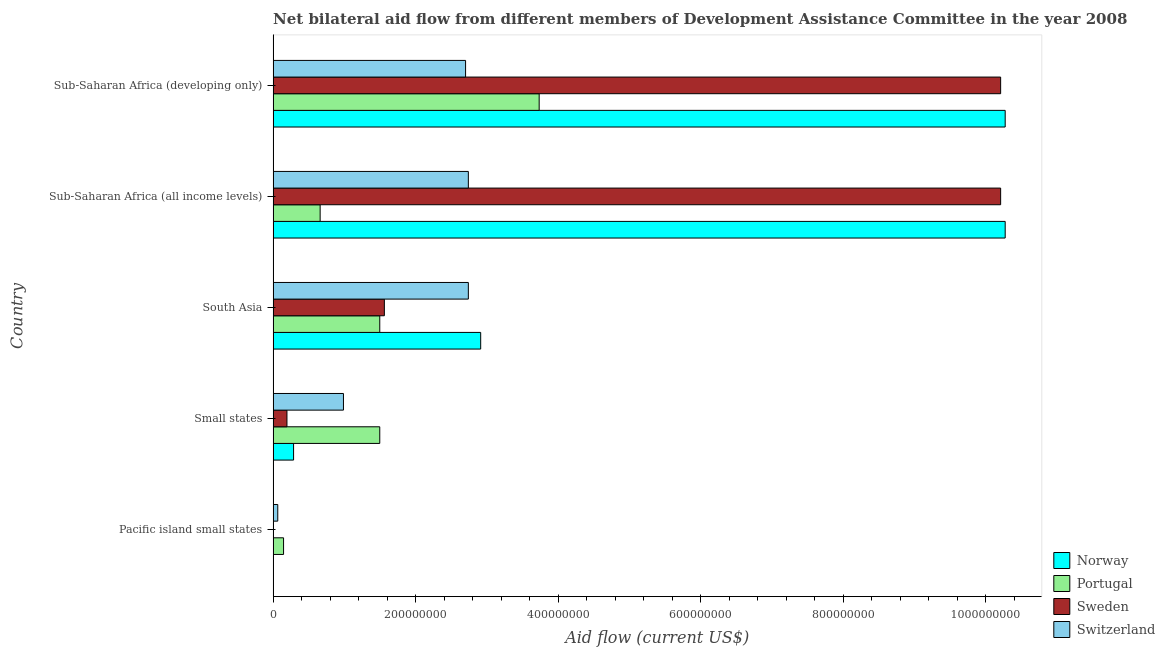How many different coloured bars are there?
Provide a succinct answer. 4. How many groups of bars are there?
Provide a short and direct response. 5. Are the number of bars per tick equal to the number of legend labels?
Provide a succinct answer. Yes. How many bars are there on the 1st tick from the bottom?
Your answer should be compact. 4. What is the label of the 5th group of bars from the top?
Give a very brief answer. Pacific island small states. In how many cases, is the number of bars for a given country not equal to the number of legend labels?
Offer a very short reply. 0. What is the amount of aid given by portugal in Small states?
Give a very brief answer. 1.50e+08. Across all countries, what is the maximum amount of aid given by switzerland?
Provide a short and direct response. 2.74e+08. Across all countries, what is the minimum amount of aid given by sweden?
Your answer should be very brief. 7.00e+04. In which country was the amount of aid given by norway maximum?
Make the answer very short. Sub-Saharan Africa (all income levels). In which country was the amount of aid given by norway minimum?
Give a very brief answer. Pacific island small states. What is the total amount of aid given by portugal in the graph?
Provide a succinct answer. 7.53e+08. What is the difference between the amount of aid given by norway in Small states and that in South Asia?
Ensure brevity in your answer.  -2.63e+08. What is the difference between the amount of aid given by portugal in South Asia and the amount of aid given by switzerland in Small states?
Give a very brief answer. 5.10e+07. What is the average amount of aid given by portugal per country?
Your response must be concise. 1.51e+08. What is the difference between the amount of aid given by portugal and amount of aid given by norway in Sub-Saharan Africa (all income levels)?
Offer a very short reply. -9.61e+08. In how many countries, is the amount of aid given by portugal greater than 680000000 US$?
Provide a short and direct response. 0. What is the ratio of the amount of aid given by sweden in South Asia to that in Sub-Saharan Africa (developing only)?
Offer a very short reply. 0.15. Is the amount of aid given by norway in Sub-Saharan Africa (all income levels) less than that in Sub-Saharan Africa (developing only)?
Offer a terse response. No. What is the difference between the highest and the lowest amount of aid given by portugal?
Offer a terse response. 3.59e+08. In how many countries, is the amount of aid given by sweden greater than the average amount of aid given by sweden taken over all countries?
Ensure brevity in your answer.  2. Is it the case that in every country, the sum of the amount of aid given by sweden and amount of aid given by portugal is greater than the sum of amount of aid given by switzerland and amount of aid given by norway?
Your response must be concise. No. What does the 3rd bar from the top in South Asia represents?
Make the answer very short. Portugal. What does the 4th bar from the bottom in Sub-Saharan Africa (developing only) represents?
Your response must be concise. Switzerland. Is it the case that in every country, the sum of the amount of aid given by norway and amount of aid given by portugal is greater than the amount of aid given by sweden?
Offer a terse response. Yes. Does the graph contain any zero values?
Keep it short and to the point. No. How are the legend labels stacked?
Your answer should be very brief. Vertical. What is the title of the graph?
Provide a short and direct response. Net bilateral aid flow from different members of Development Assistance Committee in the year 2008. Does "Efficiency of custom clearance process" appear as one of the legend labels in the graph?
Your response must be concise. No. What is the label or title of the Y-axis?
Offer a very short reply. Country. What is the Aid flow (current US$) of Portugal in Pacific island small states?
Offer a very short reply. 1.46e+07. What is the Aid flow (current US$) of Sweden in Pacific island small states?
Ensure brevity in your answer.  7.00e+04. What is the Aid flow (current US$) of Switzerland in Pacific island small states?
Your response must be concise. 6.52e+06. What is the Aid flow (current US$) in Norway in Small states?
Make the answer very short. 2.87e+07. What is the Aid flow (current US$) in Portugal in Small states?
Give a very brief answer. 1.50e+08. What is the Aid flow (current US$) of Sweden in Small states?
Ensure brevity in your answer.  1.94e+07. What is the Aid flow (current US$) in Switzerland in Small states?
Your answer should be compact. 9.87e+07. What is the Aid flow (current US$) of Norway in South Asia?
Your response must be concise. 2.91e+08. What is the Aid flow (current US$) of Portugal in South Asia?
Keep it short and to the point. 1.50e+08. What is the Aid flow (current US$) in Sweden in South Asia?
Keep it short and to the point. 1.56e+08. What is the Aid flow (current US$) in Switzerland in South Asia?
Keep it short and to the point. 2.74e+08. What is the Aid flow (current US$) in Norway in Sub-Saharan Africa (all income levels)?
Your response must be concise. 1.03e+09. What is the Aid flow (current US$) of Portugal in Sub-Saharan Africa (all income levels)?
Provide a short and direct response. 6.60e+07. What is the Aid flow (current US$) of Sweden in Sub-Saharan Africa (all income levels)?
Provide a short and direct response. 1.02e+09. What is the Aid flow (current US$) of Switzerland in Sub-Saharan Africa (all income levels)?
Your answer should be very brief. 2.74e+08. What is the Aid flow (current US$) of Norway in Sub-Saharan Africa (developing only)?
Give a very brief answer. 1.03e+09. What is the Aid flow (current US$) in Portugal in Sub-Saharan Africa (developing only)?
Provide a short and direct response. 3.73e+08. What is the Aid flow (current US$) of Sweden in Sub-Saharan Africa (developing only)?
Your answer should be very brief. 1.02e+09. What is the Aid flow (current US$) of Switzerland in Sub-Saharan Africa (developing only)?
Make the answer very short. 2.70e+08. Across all countries, what is the maximum Aid flow (current US$) of Norway?
Provide a short and direct response. 1.03e+09. Across all countries, what is the maximum Aid flow (current US$) in Portugal?
Make the answer very short. 3.73e+08. Across all countries, what is the maximum Aid flow (current US$) in Sweden?
Give a very brief answer. 1.02e+09. Across all countries, what is the maximum Aid flow (current US$) in Switzerland?
Offer a terse response. 2.74e+08. Across all countries, what is the minimum Aid flow (current US$) in Portugal?
Provide a short and direct response. 1.46e+07. Across all countries, what is the minimum Aid flow (current US$) of Sweden?
Give a very brief answer. 7.00e+04. Across all countries, what is the minimum Aid flow (current US$) of Switzerland?
Make the answer very short. 6.52e+06. What is the total Aid flow (current US$) in Norway in the graph?
Provide a succinct answer. 2.38e+09. What is the total Aid flow (current US$) in Portugal in the graph?
Provide a succinct answer. 7.53e+08. What is the total Aid flow (current US$) of Sweden in the graph?
Make the answer very short. 2.22e+09. What is the total Aid flow (current US$) of Switzerland in the graph?
Provide a short and direct response. 9.23e+08. What is the difference between the Aid flow (current US$) of Norway in Pacific island small states and that in Small states?
Keep it short and to the point. -2.87e+07. What is the difference between the Aid flow (current US$) of Portugal in Pacific island small states and that in Small states?
Provide a succinct answer. -1.35e+08. What is the difference between the Aid flow (current US$) in Sweden in Pacific island small states and that in Small states?
Offer a very short reply. -1.93e+07. What is the difference between the Aid flow (current US$) in Switzerland in Pacific island small states and that in Small states?
Provide a succinct answer. -9.22e+07. What is the difference between the Aid flow (current US$) in Norway in Pacific island small states and that in South Asia?
Ensure brevity in your answer.  -2.91e+08. What is the difference between the Aid flow (current US$) of Portugal in Pacific island small states and that in South Asia?
Provide a short and direct response. -1.35e+08. What is the difference between the Aid flow (current US$) in Sweden in Pacific island small states and that in South Asia?
Offer a terse response. -1.56e+08. What is the difference between the Aid flow (current US$) of Switzerland in Pacific island small states and that in South Asia?
Provide a short and direct response. -2.67e+08. What is the difference between the Aid flow (current US$) in Norway in Pacific island small states and that in Sub-Saharan Africa (all income levels)?
Make the answer very short. -1.03e+09. What is the difference between the Aid flow (current US$) of Portugal in Pacific island small states and that in Sub-Saharan Africa (all income levels)?
Make the answer very short. -5.14e+07. What is the difference between the Aid flow (current US$) in Sweden in Pacific island small states and that in Sub-Saharan Africa (all income levels)?
Give a very brief answer. -1.02e+09. What is the difference between the Aid flow (current US$) of Switzerland in Pacific island small states and that in Sub-Saharan Africa (all income levels)?
Keep it short and to the point. -2.67e+08. What is the difference between the Aid flow (current US$) of Norway in Pacific island small states and that in Sub-Saharan Africa (developing only)?
Give a very brief answer. -1.03e+09. What is the difference between the Aid flow (current US$) of Portugal in Pacific island small states and that in Sub-Saharan Africa (developing only)?
Your answer should be compact. -3.59e+08. What is the difference between the Aid flow (current US$) in Sweden in Pacific island small states and that in Sub-Saharan Africa (developing only)?
Your answer should be very brief. -1.02e+09. What is the difference between the Aid flow (current US$) in Switzerland in Pacific island small states and that in Sub-Saharan Africa (developing only)?
Your answer should be compact. -2.64e+08. What is the difference between the Aid flow (current US$) in Norway in Small states and that in South Asia?
Keep it short and to the point. -2.63e+08. What is the difference between the Aid flow (current US$) of Portugal in Small states and that in South Asia?
Your answer should be compact. 0. What is the difference between the Aid flow (current US$) in Sweden in Small states and that in South Asia?
Offer a very short reply. -1.37e+08. What is the difference between the Aid flow (current US$) in Switzerland in Small states and that in South Asia?
Your answer should be very brief. -1.75e+08. What is the difference between the Aid flow (current US$) of Norway in Small states and that in Sub-Saharan Africa (all income levels)?
Give a very brief answer. -9.99e+08. What is the difference between the Aid flow (current US$) in Portugal in Small states and that in Sub-Saharan Africa (all income levels)?
Keep it short and to the point. 8.37e+07. What is the difference between the Aid flow (current US$) of Sweden in Small states and that in Sub-Saharan Africa (all income levels)?
Your response must be concise. -1.00e+09. What is the difference between the Aid flow (current US$) of Switzerland in Small states and that in Sub-Saharan Africa (all income levels)?
Your answer should be compact. -1.75e+08. What is the difference between the Aid flow (current US$) in Norway in Small states and that in Sub-Saharan Africa (developing only)?
Offer a terse response. -9.99e+08. What is the difference between the Aid flow (current US$) in Portugal in Small states and that in Sub-Saharan Africa (developing only)?
Make the answer very short. -2.24e+08. What is the difference between the Aid flow (current US$) of Sweden in Small states and that in Sub-Saharan Africa (developing only)?
Offer a very short reply. -1.00e+09. What is the difference between the Aid flow (current US$) in Switzerland in Small states and that in Sub-Saharan Africa (developing only)?
Give a very brief answer. -1.71e+08. What is the difference between the Aid flow (current US$) in Norway in South Asia and that in Sub-Saharan Africa (all income levels)?
Your answer should be compact. -7.36e+08. What is the difference between the Aid flow (current US$) of Portugal in South Asia and that in Sub-Saharan Africa (all income levels)?
Offer a terse response. 8.37e+07. What is the difference between the Aid flow (current US$) in Sweden in South Asia and that in Sub-Saharan Africa (all income levels)?
Your response must be concise. -8.65e+08. What is the difference between the Aid flow (current US$) in Switzerland in South Asia and that in Sub-Saharan Africa (all income levels)?
Give a very brief answer. 0. What is the difference between the Aid flow (current US$) in Norway in South Asia and that in Sub-Saharan Africa (developing only)?
Give a very brief answer. -7.36e+08. What is the difference between the Aid flow (current US$) in Portugal in South Asia and that in Sub-Saharan Africa (developing only)?
Give a very brief answer. -2.24e+08. What is the difference between the Aid flow (current US$) in Sweden in South Asia and that in Sub-Saharan Africa (developing only)?
Keep it short and to the point. -8.65e+08. What is the difference between the Aid flow (current US$) in Switzerland in South Asia and that in Sub-Saharan Africa (developing only)?
Your response must be concise. 3.90e+06. What is the difference between the Aid flow (current US$) in Portugal in Sub-Saharan Africa (all income levels) and that in Sub-Saharan Africa (developing only)?
Make the answer very short. -3.07e+08. What is the difference between the Aid flow (current US$) of Sweden in Sub-Saharan Africa (all income levels) and that in Sub-Saharan Africa (developing only)?
Offer a very short reply. 0. What is the difference between the Aid flow (current US$) of Switzerland in Sub-Saharan Africa (all income levels) and that in Sub-Saharan Africa (developing only)?
Provide a succinct answer. 3.90e+06. What is the difference between the Aid flow (current US$) of Norway in Pacific island small states and the Aid flow (current US$) of Portugal in Small states?
Keep it short and to the point. -1.50e+08. What is the difference between the Aid flow (current US$) of Norway in Pacific island small states and the Aid flow (current US$) of Sweden in Small states?
Make the answer very short. -1.94e+07. What is the difference between the Aid flow (current US$) in Norway in Pacific island small states and the Aid flow (current US$) in Switzerland in Small states?
Make the answer very short. -9.87e+07. What is the difference between the Aid flow (current US$) in Portugal in Pacific island small states and the Aid flow (current US$) in Sweden in Small states?
Ensure brevity in your answer.  -4.76e+06. What is the difference between the Aid flow (current US$) of Portugal in Pacific island small states and the Aid flow (current US$) of Switzerland in Small states?
Ensure brevity in your answer.  -8.41e+07. What is the difference between the Aid flow (current US$) of Sweden in Pacific island small states and the Aid flow (current US$) of Switzerland in Small states?
Offer a terse response. -9.86e+07. What is the difference between the Aid flow (current US$) of Norway in Pacific island small states and the Aid flow (current US$) of Portugal in South Asia?
Offer a terse response. -1.50e+08. What is the difference between the Aid flow (current US$) of Norway in Pacific island small states and the Aid flow (current US$) of Sweden in South Asia?
Keep it short and to the point. -1.56e+08. What is the difference between the Aid flow (current US$) in Norway in Pacific island small states and the Aid flow (current US$) in Switzerland in South Asia?
Offer a very short reply. -2.74e+08. What is the difference between the Aid flow (current US$) of Portugal in Pacific island small states and the Aid flow (current US$) of Sweden in South Asia?
Your answer should be compact. -1.41e+08. What is the difference between the Aid flow (current US$) in Portugal in Pacific island small states and the Aid flow (current US$) in Switzerland in South Asia?
Your answer should be very brief. -2.59e+08. What is the difference between the Aid flow (current US$) in Sweden in Pacific island small states and the Aid flow (current US$) in Switzerland in South Asia?
Make the answer very short. -2.74e+08. What is the difference between the Aid flow (current US$) in Norway in Pacific island small states and the Aid flow (current US$) in Portugal in Sub-Saharan Africa (all income levels)?
Your answer should be compact. -6.60e+07. What is the difference between the Aid flow (current US$) of Norway in Pacific island small states and the Aid flow (current US$) of Sweden in Sub-Saharan Africa (all income levels)?
Offer a very short reply. -1.02e+09. What is the difference between the Aid flow (current US$) of Norway in Pacific island small states and the Aid flow (current US$) of Switzerland in Sub-Saharan Africa (all income levels)?
Provide a succinct answer. -2.74e+08. What is the difference between the Aid flow (current US$) in Portugal in Pacific island small states and the Aid flow (current US$) in Sweden in Sub-Saharan Africa (all income levels)?
Provide a succinct answer. -1.01e+09. What is the difference between the Aid flow (current US$) of Portugal in Pacific island small states and the Aid flow (current US$) of Switzerland in Sub-Saharan Africa (all income levels)?
Offer a very short reply. -2.59e+08. What is the difference between the Aid flow (current US$) in Sweden in Pacific island small states and the Aid flow (current US$) in Switzerland in Sub-Saharan Africa (all income levels)?
Your answer should be compact. -2.74e+08. What is the difference between the Aid flow (current US$) of Norway in Pacific island small states and the Aid flow (current US$) of Portugal in Sub-Saharan Africa (developing only)?
Provide a succinct answer. -3.73e+08. What is the difference between the Aid flow (current US$) in Norway in Pacific island small states and the Aid flow (current US$) in Sweden in Sub-Saharan Africa (developing only)?
Offer a very short reply. -1.02e+09. What is the difference between the Aid flow (current US$) in Norway in Pacific island small states and the Aid flow (current US$) in Switzerland in Sub-Saharan Africa (developing only)?
Ensure brevity in your answer.  -2.70e+08. What is the difference between the Aid flow (current US$) of Portugal in Pacific island small states and the Aid flow (current US$) of Sweden in Sub-Saharan Africa (developing only)?
Provide a succinct answer. -1.01e+09. What is the difference between the Aid flow (current US$) of Portugal in Pacific island small states and the Aid flow (current US$) of Switzerland in Sub-Saharan Africa (developing only)?
Provide a succinct answer. -2.55e+08. What is the difference between the Aid flow (current US$) of Sweden in Pacific island small states and the Aid flow (current US$) of Switzerland in Sub-Saharan Africa (developing only)?
Offer a very short reply. -2.70e+08. What is the difference between the Aid flow (current US$) in Norway in Small states and the Aid flow (current US$) in Portugal in South Asia?
Your response must be concise. -1.21e+08. What is the difference between the Aid flow (current US$) in Norway in Small states and the Aid flow (current US$) in Sweden in South Asia?
Offer a terse response. -1.27e+08. What is the difference between the Aid flow (current US$) of Norway in Small states and the Aid flow (current US$) of Switzerland in South Asia?
Keep it short and to the point. -2.45e+08. What is the difference between the Aid flow (current US$) in Portugal in Small states and the Aid flow (current US$) in Sweden in South Asia?
Offer a very short reply. -6.46e+06. What is the difference between the Aid flow (current US$) of Portugal in Small states and the Aid flow (current US$) of Switzerland in South Asia?
Keep it short and to the point. -1.24e+08. What is the difference between the Aid flow (current US$) in Sweden in Small states and the Aid flow (current US$) in Switzerland in South Asia?
Provide a succinct answer. -2.55e+08. What is the difference between the Aid flow (current US$) of Norway in Small states and the Aid flow (current US$) of Portugal in Sub-Saharan Africa (all income levels)?
Your answer should be compact. -3.73e+07. What is the difference between the Aid flow (current US$) in Norway in Small states and the Aid flow (current US$) in Sweden in Sub-Saharan Africa (all income levels)?
Ensure brevity in your answer.  -9.92e+08. What is the difference between the Aid flow (current US$) in Norway in Small states and the Aid flow (current US$) in Switzerland in Sub-Saharan Africa (all income levels)?
Your response must be concise. -2.45e+08. What is the difference between the Aid flow (current US$) in Portugal in Small states and the Aid flow (current US$) in Sweden in Sub-Saharan Africa (all income levels)?
Offer a very short reply. -8.71e+08. What is the difference between the Aid flow (current US$) of Portugal in Small states and the Aid flow (current US$) of Switzerland in Sub-Saharan Africa (all income levels)?
Provide a short and direct response. -1.24e+08. What is the difference between the Aid flow (current US$) of Sweden in Small states and the Aid flow (current US$) of Switzerland in Sub-Saharan Africa (all income levels)?
Your response must be concise. -2.55e+08. What is the difference between the Aid flow (current US$) of Norway in Small states and the Aid flow (current US$) of Portugal in Sub-Saharan Africa (developing only)?
Ensure brevity in your answer.  -3.45e+08. What is the difference between the Aid flow (current US$) of Norway in Small states and the Aid flow (current US$) of Sweden in Sub-Saharan Africa (developing only)?
Ensure brevity in your answer.  -9.92e+08. What is the difference between the Aid flow (current US$) of Norway in Small states and the Aid flow (current US$) of Switzerland in Sub-Saharan Africa (developing only)?
Your answer should be very brief. -2.41e+08. What is the difference between the Aid flow (current US$) in Portugal in Small states and the Aid flow (current US$) in Sweden in Sub-Saharan Africa (developing only)?
Your response must be concise. -8.71e+08. What is the difference between the Aid flow (current US$) in Portugal in Small states and the Aid flow (current US$) in Switzerland in Sub-Saharan Africa (developing only)?
Your answer should be very brief. -1.20e+08. What is the difference between the Aid flow (current US$) in Sweden in Small states and the Aid flow (current US$) in Switzerland in Sub-Saharan Africa (developing only)?
Offer a terse response. -2.51e+08. What is the difference between the Aid flow (current US$) in Norway in South Asia and the Aid flow (current US$) in Portugal in Sub-Saharan Africa (all income levels)?
Your answer should be compact. 2.25e+08. What is the difference between the Aid flow (current US$) of Norway in South Asia and the Aid flow (current US$) of Sweden in Sub-Saharan Africa (all income levels)?
Give a very brief answer. -7.30e+08. What is the difference between the Aid flow (current US$) in Norway in South Asia and the Aid flow (current US$) in Switzerland in Sub-Saharan Africa (all income levels)?
Provide a succinct answer. 1.73e+07. What is the difference between the Aid flow (current US$) in Portugal in South Asia and the Aid flow (current US$) in Sweden in Sub-Saharan Africa (all income levels)?
Your answer should be compact. -8.71e+08. What is the difference between the Aid flow (current US$) in Portugal in South Asia and the Aid flow (current US$) in Switzerland in Sub-Saharan Africa (all income levels)?
Keep it short and to the point. -1.24e+08. What is the difference between the Aid flow (current US$) in Sweden in South Asia and the Aid flow (current US$) in Switzerland in Sub-Saharan Africa (all income levels)?
Offer a terse response. -1.18e+08. What is the difference between the Aid flow (current US$) of Norway in South Asia and the Aid flow (current US$) of Portugal in Sub-Saharan Africa (developing only)?
Give a very brief answer. -8.21e+07. What is the difference between the Aid flow (current US$) in Norway in South Asia and the Aid flow (current US$) in Sweden in Sub-Saharan Africa (developing only)?
Offer a terse response. -7.30e+08. What is the difference between the Aid flow (current US$) of Norway in South Asia and the Aid flow (current US$) of Switzerland in Sub-Saharan Africa (developing only)?
Your answer should be compact. 2.12e+07. What is the difference between the Aid flow (current US$) of Portugal in South Asia and the Aid flow (current US$) of Sweden in Sub-Saharan Africa (developing only)?
Make the answer very short. -8.71e+08. What is the difference between the Aid flow (current US$) in Portugal in South Asia and the Aid flow (current US$) in Switzerland in Sub-Saharan Africa (developing only)?
Your answer should be very brief. -1.20e+08. What is the difference between the Aid flow (current US$) in Sweden in South Asia and the Aid flow (current US$) in Switzerland in Sub-Saharan Africa (developing only)?
Offer a terse response. -1.14e+08. What is the difference between the Aid flow (current US$) of Norway in Sub-Saharan Africa (all income levels) and the Aid flow (current US$) of Portugal in Sub-Saharan Africa (developing only)?
Your response must be concise. 6.54e+08. What is the difference between the Aid flow (current US$) of Norway in Sub-Saharan Africa (all income levels) and the Aid flow (current US$) of Sweden in Sub-Saharan Africa (developing only)?
Your answer should be very brief. 6.38e+06. What is the difference between the Aid flow (current US$) in Norway in Sub-Saharan Africa (all income levels) and the Aid flow (current US$) in Switzerland in Sub-Saharan Africa (developing only)?
Keep it short and to the point. 7.57e+08. What is the difference between the Aid flow (current US$) in Portugal in Sub-Saharan Africa (all income levels) and the Aid flow (current US$) in Sweden in Sub-Saharan Africa (developing only)?
Provide a short and direct response. -9.55e+08. What is the difference between the Aid flow (current US$) in Portugal in Sub-Saharan Africa (all income levels) and the Aid flow (current US$) in Switzerland in Sub-Saharan Africa (developing only)?
Ensure brevity in your answer.  -2.04e+08. What is the difference between the Aid flow (current US$) of Sweden in Sub-Saharan Africa (all income levels) and the Aid flow (current US$) of Switzerland in Sub-Saharan Africa (developing only)?
Offer a very short reply. 7.51e+08. What is the average Aid flow (current US$) in Norway per country?
Give a very brief answer. 4.75e+08. What is the average Aid flow (current US$) in Portugal per country?
Provide a succinct answer. 1.51e+08. What is the average Aid flow (current US$) in Sweden per country?
Your response must be concise. 4.44e+08. What is the average Aid flow (current US$) in Switzerland per country?
Ensure brevity in your answer.  1.85e+08. What is the difference between the Aid flow (current US$) in Norway and Aid flow (current US$) in Portugal in Pacific island small states?
Provide a short and direct response. -1.46e+07. What is the difference between the Aid flow (current US$) in Norway and Aid flow (current US$) in Sweden in Pacific island small states?
Keep it short and to the point. -2.00e+04. What is the difference between the Aid flow (current US$) in Norway and Aid flow (current US$) in Switzerland in Pacific island small states?
Make the answer very short. -6.47e+06. What is the difference between the Aid flow (current US$) of Portugal and Aid flow (current US$) of Sweden in Pacific island small states?
Your response must be concise. 1.46e+07. What is the difference between the Aid flow (current US$) of Portugal and Aid flow (current US$) of Switzerland in Pacific island small states?
Offer a terse response. 8.13e+06. What is the difference between the Aid flow (current US$) in Sweden and Aid flow (current US$) in Switzerland in Pacific island small states?
Your response must be concise. -6.45e+06. What is the difference between the Aid flow (current US$) of Norway and Aid flow (current US$) of Portugal in Small states?
Make the answer very short. -1.21e+08. What is the difference between the Aid flow (current US$) in Norway and Aid flow (current US$) in Sweden in Small states?
Offer a terse response. 9.30e+06. What is the difference between the Aid flow (current US$) in Norway and Aid flow (current US$) in Switzerland in Small states?
Ensure brevity in your answer.  -7.00e+07. What is the difference between the Aid flow (current US$) of Portugal and Aid flow (current US$) of Sweden in Small states?
Ensure brevity in your answer.  1.30e+08. What is the difference between the Aid flow (current US$) of Portugal and Aid flow (current US$) of Switzerland in Small states?
Provide a short and direct response. 5.10e+07. What is the difference between the Aid flow (current US$) in Sweden and Aid flow (current US$) in Switzerland in Small states?
Your answer should be very brief. -7.93e+07. What is the difference between the Aid flow (current US$) in Norway and Aid flow (current US$) in Portugal in South Asia?
Provide a succinct answer. 1.42e+08. What is the difference between the Aid flow (current US$) in Norway and Aid flow (current US$) in Sweden in South Asia?
Give a very brief answer. 1.35e+08. What is the difference between the Aid flow (current US$) in Norway and Aid flow (current US$) in Switzerland in South Asia?
Give a very brief answer. 1.73e+07. What is the difference between the Aid flow (current US$) in Portugal and Aid flow (current US$) in Sweden in South Asia?
Make the answer very short. -6.46e+06. What is the difference between the Aid flow (current US$) of Portugal and Aid flow (current US$) of Switzerland in South Asia?
Ensure brevity in your answer.  -1.24e+08. What is the difference between the Aid flow (current US$) of Sweden and Aid flow (current US$) of Switzerland in South Asia?
Your answer should be compact. -1.18e+08. What is the difference between the Aid flow (current US$) in Norway and Aid flow (current US$) in Portugal in Sub-Saharan Africa (all income levels)?
Offer a terse response. 9.61e+08. What is the difference between the Aid flow (current US$) of Norway and Aid flow (current US$) of Sweden in Sub-Saharan Africa (all income levels)?
Provide a succinct answer. 6.38e+06. What is the difference between the Aid flow (current US$) of Norway and Aid flow (current US$) of Switzerland in Sub-Saharan Africa (all income levels)?
Make the answer very short. 7.53e+08. What is the difference between the Aid flow (current US$) of Portugal and Aid flow (current US$) of Sweden in Sub-Saharan Africa (all income levels)?
Give a very brief answer. -9.55e+08. What is the difference between the Aid flow (current US$) in Portugal and Aid flow (current US$) in Switzerland in Sub-Saharan Africa (all income levels)?
Make the answer very short. -2.08e+08. What is the difference between the Aid flow (current US$) in Sweden and Aid flow (current US$) in Switzerland in Sub-Saharan Africa (all income levels)?
Offer a terse response. 7.47e+08. What is the difference between the Aid flow (current US$) of Norway and Aid flow (current US$) of Portugal in Sub-Saharan Africa (developing only)?
Your response must be concise. 6.54e+08. What is the difference between the Aid flow (current US$) of Norway and Aid flow (current US$) of Sweden in Sub-Saharan Africa (developing only)?
Give a very brief answer. 6.38e+06. What is the difference between the Aid flow (current US$) of Norway and Aid flow (current US$) of Switzerland in Sub-Saharan Africa (developing only)?
Make the answer very short. 7.57e+08. What is the difference between the Aid flow (current US$) of Portugal and Aid flow (current US$) of Sweden in Sub-Saharan Africa (developing only)?
Offer a terse response. -6.48e+08. What is the difference between the Aid flow (current US$) in Portugal and Aid flow (current US$) in Switzerland in Sub-Saharan Africa (developing only)?
Make the answer very short. 1.03e+08. What is the difference between the Aid flow (current US$) in Sweden and Aid flow (current US$) in Switzerland in Sub-Saharan Africa (developing only)?
Your answer should be compact. 7.51e+08. What is the ratio of the Aid flow (current US$) in Norway in Pacific island small states to that in Small states?
Offer a terse response. 0. What is the ratio of the Aid flow (current US$) of Portugal in Pacific island small states to that in Small states?
Ensure brevity in your answer.  0.1. What is the ratio of the Aid flow (current US$) of Sweden in Pacific island small states to that in Small states?
Offer a very short reply. 0. What is the ratio of the Aid flow (current US$) of Switzerland in Pacific island small states to that in Small states?
Your response must be concise. 0.07. What is the ratio of the Aid flow (current US$) of Norway in Pacific island small states to that in South Asia?
Keep it short and to the point. 0. What is the ratio of the Aid flow (current US$) in Portugal in Pacific island small states to that in South Asia?
Your response must be concise. 0.1. What is the ratio of the Aid flow (current US$) in Sweden in Pacific island small states to that in South Asia?
Offer a terse response. 0. What is the ratio of the Aid flow (current US$) of Switzerland in Pacific island small states to that in South Asia?
Offer a very short reply. 0.02. What is the ratio of the Aid flow (current US$) in Portugal in Pacific island small states to that in Sub-Saharan Africa (all income levels)?
Keep it short and to the point. 0.22. What is the ratio of the Aid flow (current US$) of Switzerland in Pacific island small states to that in Sub-Saharan Africa (all income levels)?
Your answer should be compact. 0.02. What is the ratio of the Aid flow (current US$) in Norway in Pacific island small states to that in Sub-Saharan Africa (developing only)?
Your answer should be very brief. 0. What is the ratio of the Aid flow (current US$) in Portugal in Pacific island small states to that in Sub-Saharan Africa (developing only)?
Make the answer very short. 0.04. What is the ratio of the Aid flow (current US$) in Switzerland in Pacific island small states to that in Sub-Saharan Africa (developing only)?
Make the answer very short. 0.02. What is the ratio of the Aid flow (current US$) of Norway in Small states to that in South Asia?
Ensure brevity in your answer.  0.1. What is the ratio of the Aid flow (current US$) in Portugal in Small states to that in South Asia?
Your answer should be compact. 1. What is the ratio of the Aid flow (current US$) in Sweden in Small states to that in South Asia?
Your answer should be compact. 0.12. What is the ratio of the Aid flow (current US$) of Switzerland in Small states to that in South Asia?
Offer a very short reply. 0.36. What is the ratio of the Aid flow (current US$) of Norway in Small states to that in Sub-Saharan Africa (all income levels)?
Your response must be concise. 0.03. What is the ratio of the Aid flow (current US$) in Portugal in Small states to that in Sub-Saharan Africa (all income levels)?
Your response must be concise. 2.27. What is the ratio of the Aid flow (current US$) in Sweden in Small states to that in Sub-Saharan Africa (all income levels)?
Give a very brief answer. 0.02. What is the ratio of the Aid flow (current US$) in Switzerland in Small states to that in Sub-Saharan Africa (all income levels)?
Give a very brief answer. 0.36. What is the ratio of the Aid flow (current US$) in Norway in Small states to that in Sub-Saharan Africa (developing only)?
Keep it short and to the point. 0.03. What is the ratio of the Aid flow (current US$) in Portugal in Small states to that in Sub-Saharan Africa (developing only)?
Your response must be concise. 0.4. What is the ratio of the Aid flow (current US$) in Sweden in Small states to that in Sub-Saharan Africa (developing only)?
Make the answer very short. 0.02. What is the ratio of the Aid flow (current US$) of Switzerland in Small states to that in Sub-Saharan Africa (developing only)?
Make the answer very short. 0.37. What is the ratio of the Aid flow (current US$) of Norway in South Asia to that in Sub-Saharan Africa (all income levels)?
Keep it short and to the point. 0.28. What is the ratio of the Aid flow (current US$) of Portugal in South Asia to that in Sub-Saharan Africa (all income levels)?
Make the answer very short. 2.27. What is the ratio of the Aid flow (current US$) in Sweden in South Asia to that in Sub-Saharan Africa (all income levels)?
Provide a short and direct response. 0.15. What is the ratio of the Aid flow (current US$) of Norway in South Asia to that in Sub-Saharan Africa (developing only)?
Provide a succinct answer. 0.28. What is the ratio of the Aid flow (current US$) in Portugal in South Asia to that in Sub-Saharan Africa (developing only)?
Make the answer very short. 0.4. What is the ratio of the Aid flow (current US$) of Sweden in South Asia to that in Sub-Saharan Africa (developing only)?
Ensure brevity in your answer.  0.15. What is the ratio of the Aid flow (current US$) of Switzerland in South Asia to that in Sub-Saharan Africa (developing only)?
Your answer should be very brief. 1.01. What is the ratio of the Aid flow (current US$) in Portugal in Sub-Saharan Africa (all income levels) to that in Sub-Saharan Africa (developing only)?
Your response must be concise. 0.18. What is the ratio of the Aid flow (current US$) of Sweden in Sub-Saharan Africa (all income levels) to that in Sub-Saharan Africa (developing only)?
Offer a very short reply. 1. What is the ratio of the Aid flow (current US$) in Switzerland in Sub-Saharan Africa (all income levels) to that in Sub-Saharan Africa (developing only)?
Your answer should be compact. 1.01. What is the difference between the highest and the second highest Aid flow (current US$) in Norway?
Offer a very short reply. 0. What is the difference between the highest and the second highest Aid flow (current US$) of Portugal?
Provide a succinct answer. 2.24e+08. What is the difference between the highest and the lowest Aid flow (current US$) in Norway?
Your answer should be very brief. 1.03e+09. What is the difference between the highest and the lowest Aid flow (current US$) in Portugal?
Give a very brief answer. 3.59e+08. What is the difference between the highest and the lowest Aid flow (current US$) in Sweden?
Keep it short and to the point. 1.02e+09. What is the difference between the highest and the lowest Aid flow (current US$) in Switzerland?
Provide a succinct answer. 2.67e+08. 